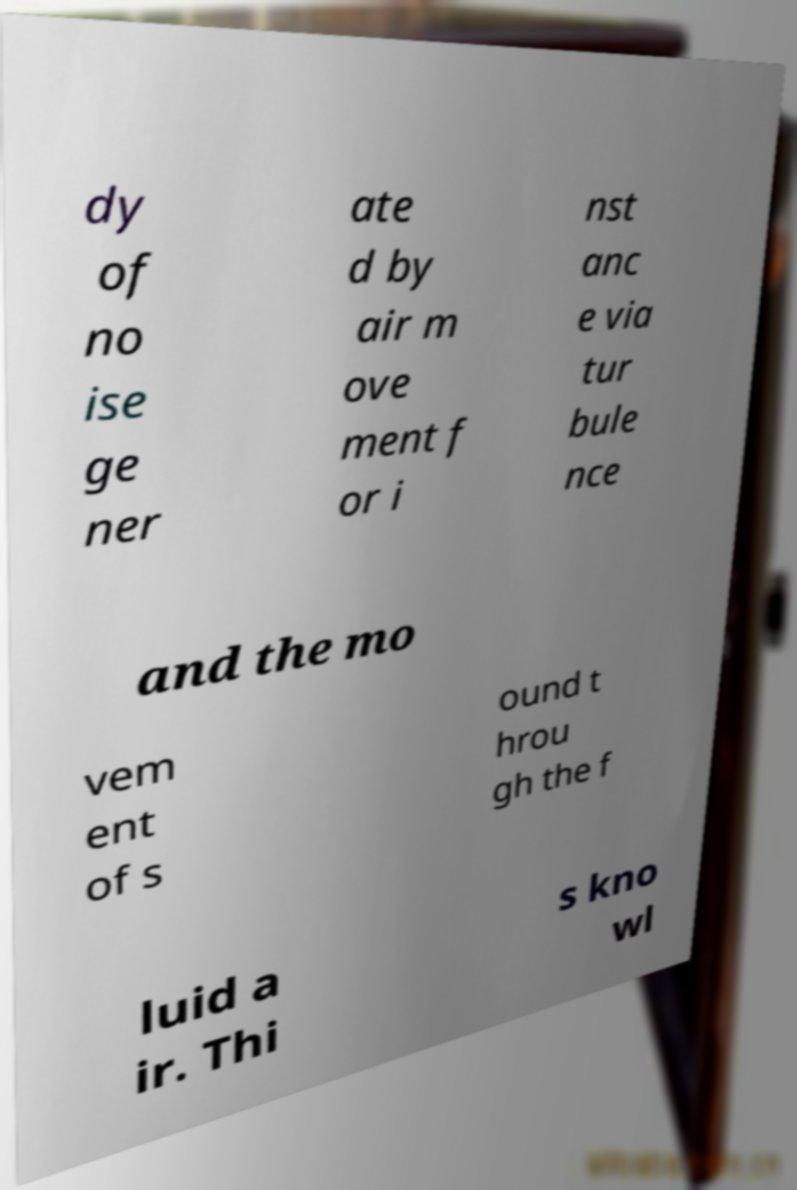Please read and relay the text visible in this image. What does it say? dy of no ise ge ner ate d by air m ove ment f or i nst anc e via tur bule nce and the mo vem ent of s ound t hrou gh the f luid a ir. Thi s kno wl 